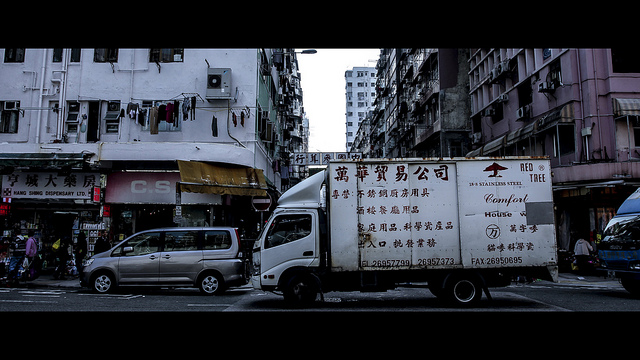<image>What is the name of the restaurant? I don't know the name of the restaurant. It could be 'cs' or 'red tree'. What is the name of the restaurant? I am not sure what is the name of the restaurant. It can be 'cs', 'red tree' or something else. 